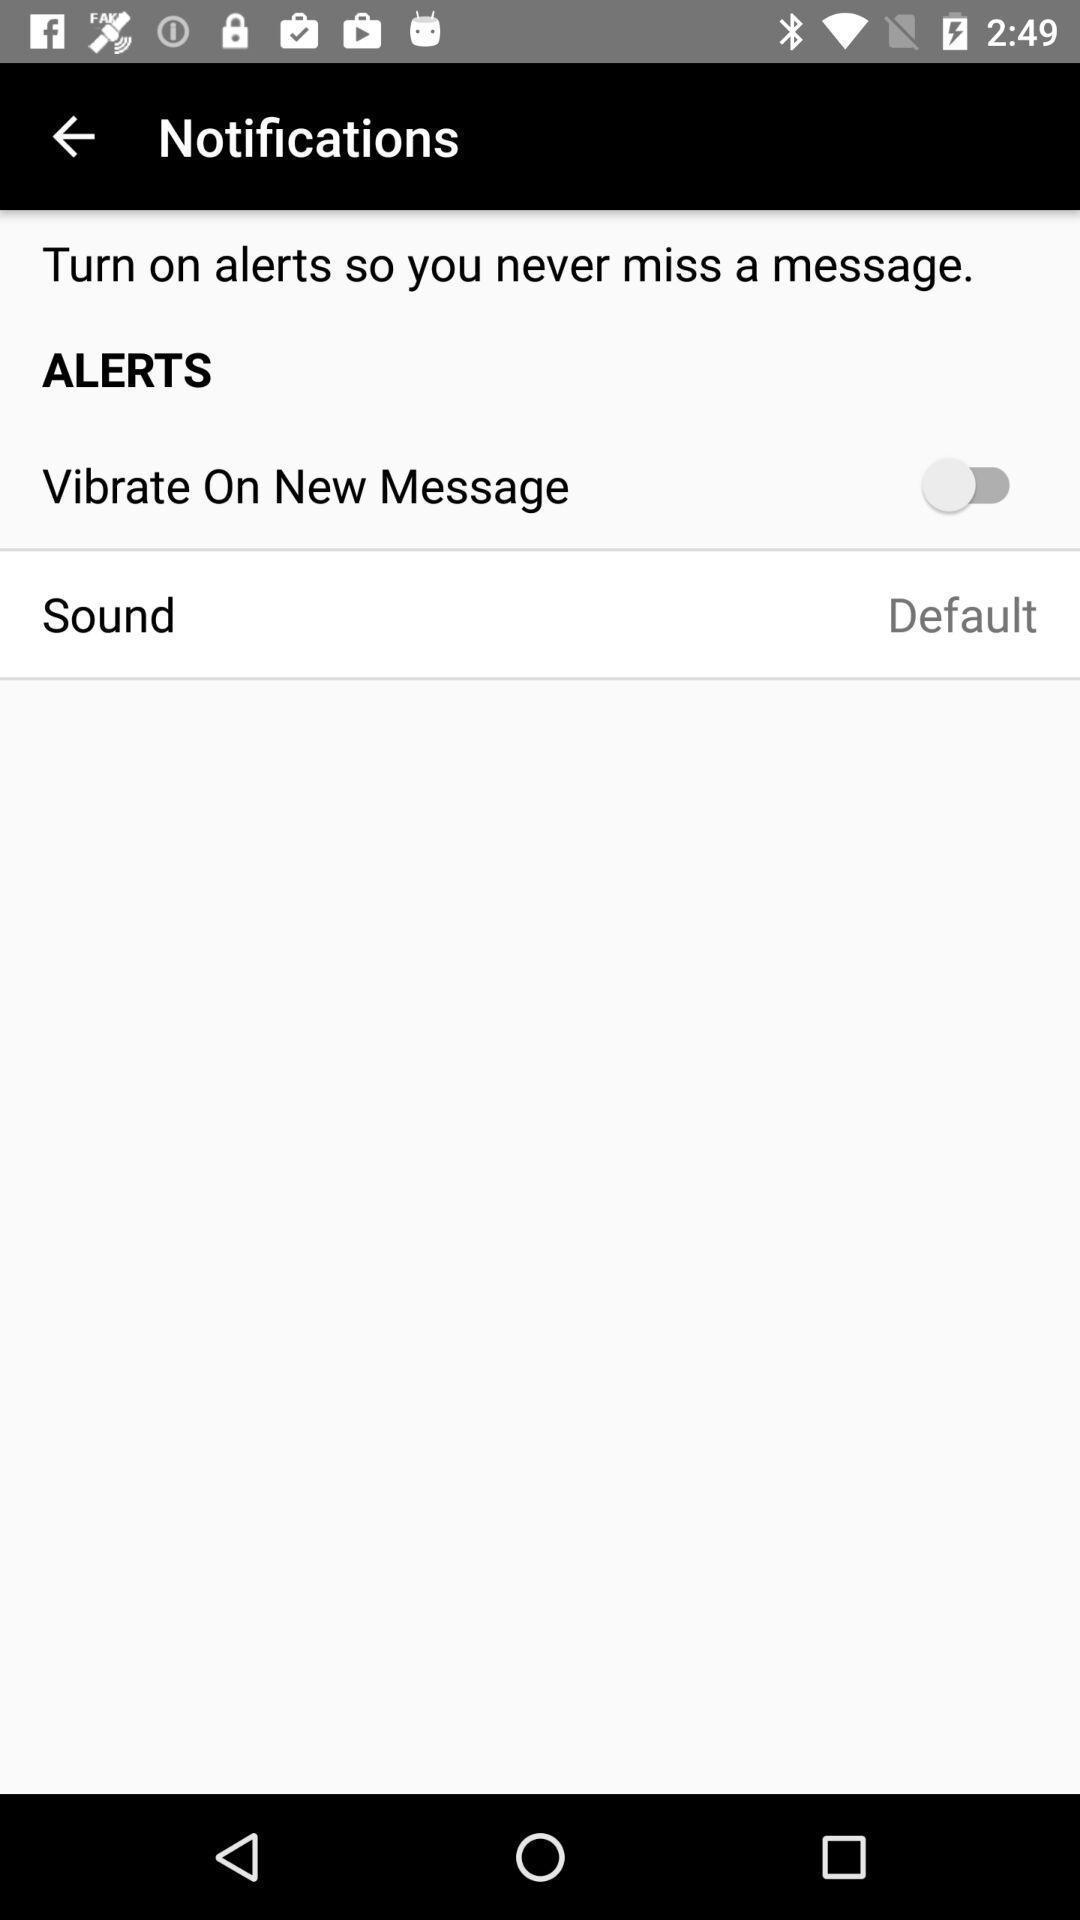What can you discern from this picture? Page displaying option for message alerts. 